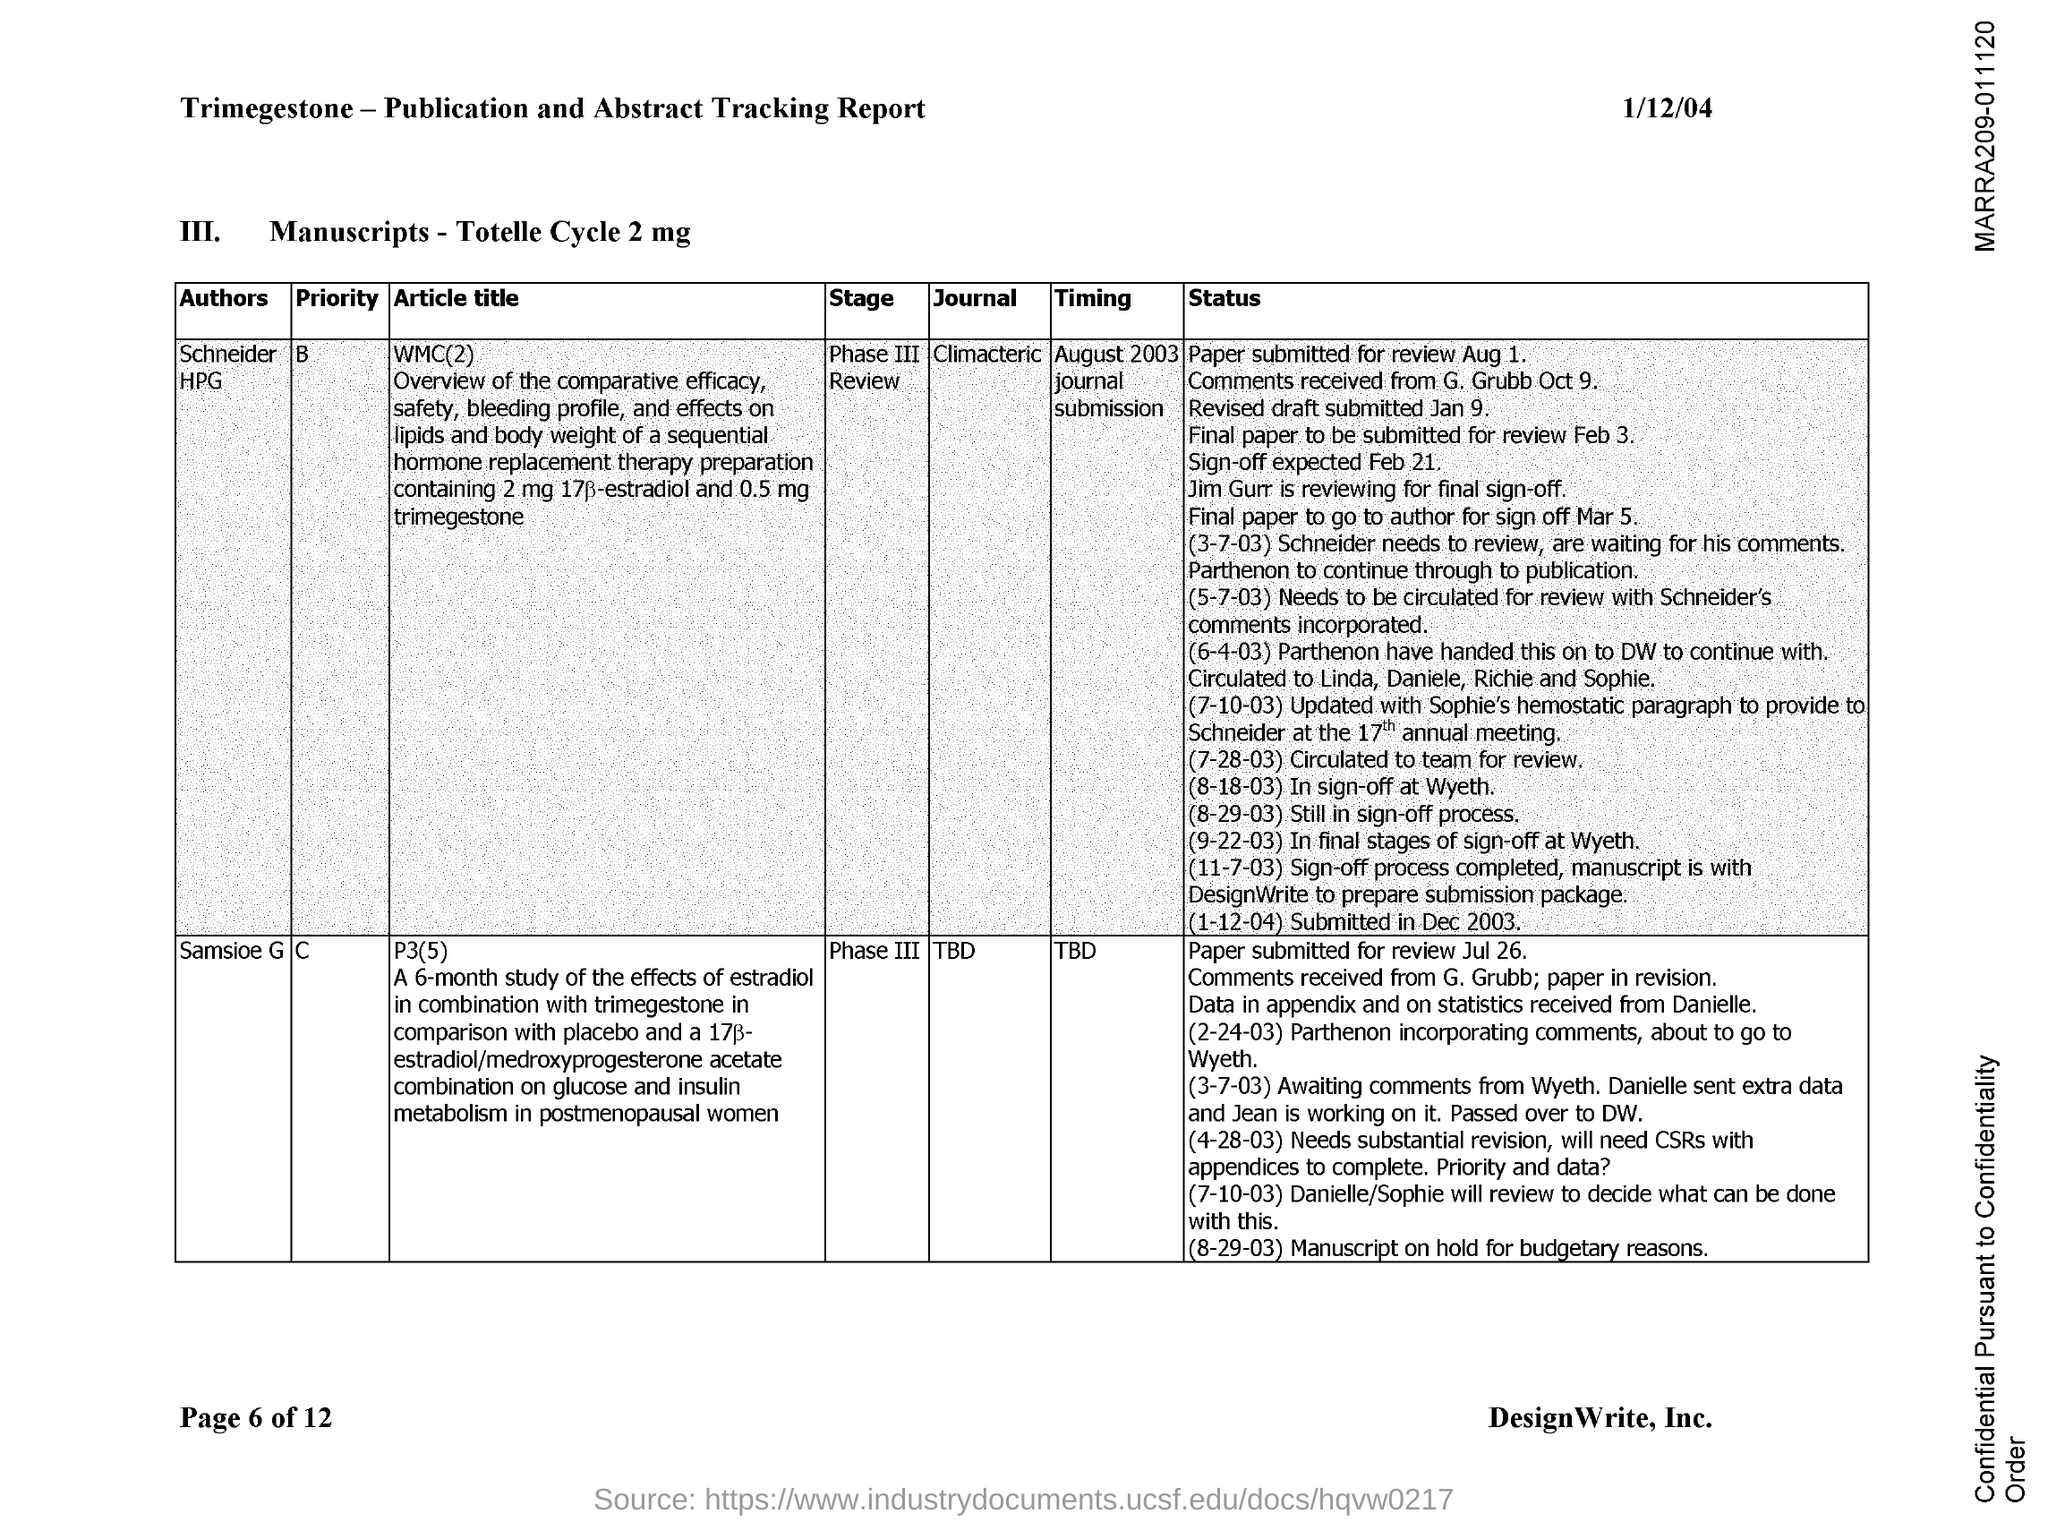When is the document dated?
Offer a very short reply. 1/12/04. Who is the author of WMC(2)?
Make the answer very short. Schneider HPG. What is the stage of P3(5)?
Offer a terse response. Phase III. When is the timing of WMC(2)?
Your answer should be very brief. August 2003. 